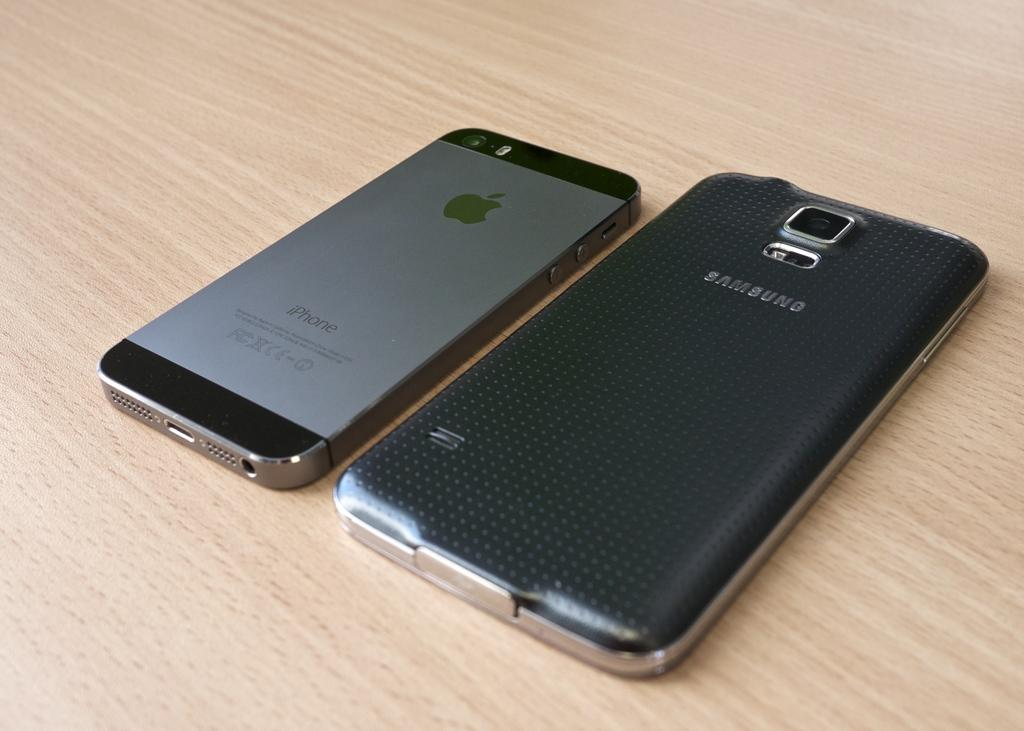<image>
Describe the image concisely. a word that is on the phone called Samsung 